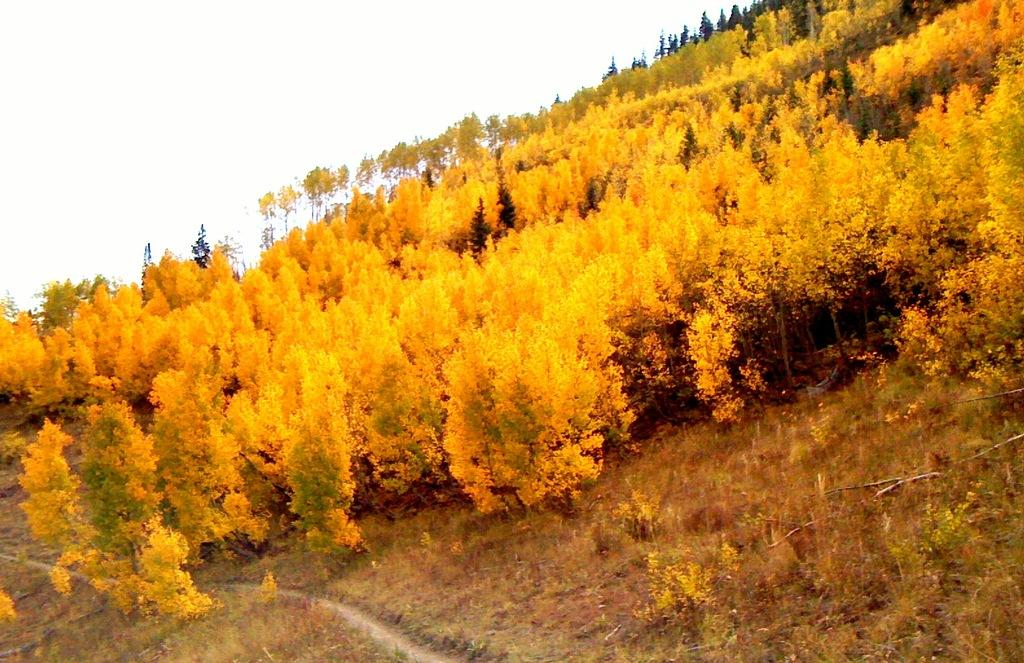What color are the trees in the image? The trees in the image are yellow in color. What type of vegetation is visible on the ground in the image? There is grass visible in the image. What can be seen in the background of the image? The sky is visible in the background of the image. Where is the spy hiding in the image? There is no spy present in the image. What type of plant is the cactus in the image? There is no cactus present in the image. 